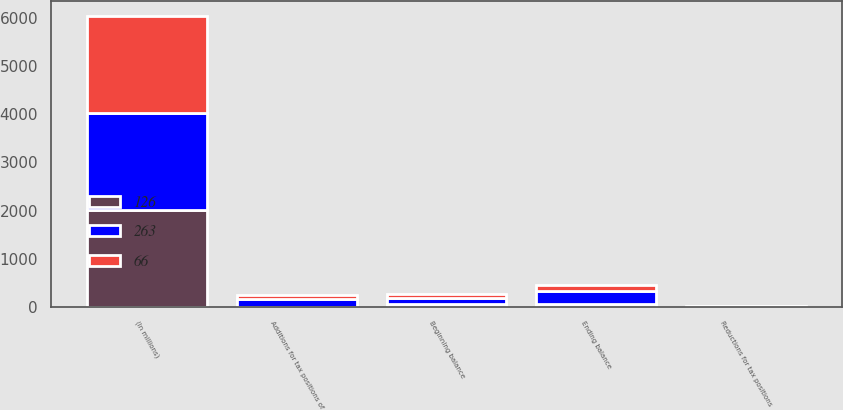<chart> <loc_0><loc_0><loc_500><loc_500><stacked_bar_chart><ecel><fcel>(In millions)<fcel>Beginning balance<fcel>Additions for tax positions of<fcel>Reductions for tax positions<fcel>Ending balance<nl><fcel>263<fcel>2018<fcel>126<fcel>152<fcel>15<fcel>263<nl><fcel>66<fcel>2017<fcel>66<fcel>83<fcel>3<fcel>126<nl><fcel>126<fcel>2016<fcel>65<fcel>6<fcel>5<fcel>66<nl></chart> 